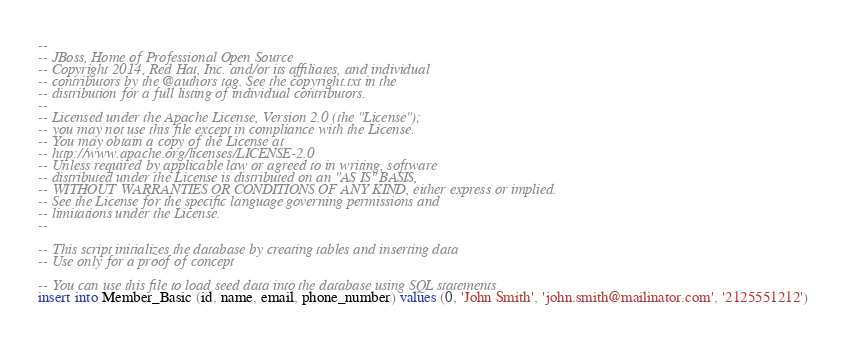Convert code to text. <code><loc_0><loc_0><loc_500><loc_500><_SQL_>--
-- JBoss, Home of Professional Open Source
-- Copyright 2014, Red Hat, Inc. and/or its affiliates, and individual
-- contributors by the @authors tag. See the copyright.txt in the
-- distribution for a full listing of individual contributors.
--
-- Licensed under the Apache License, Version 2.0 (the "License");
-- you may not use this file except in compliance with the License.
-- You may obtain a copy of the License at
-- http://www.apache.org/licenses/LICENSE-2.0
-- Unless required by applicable law or agreed to in writing, software
-- distributed under the License is distributed on an "AS IS" BASIS,
-- WITHOUT WARRANTIES OR CONDITIONS OF ANY KIND, either express or implied.
-- See the License for the specific language governing permissions and
-- limitations under the License.
--

-- This script initializes the database by creating tables and inserting data
-- Use only for a proof of concept

-- You can use this file to load seed data into the database using SQL statements
insert into Member_Basic (id, name, email, phone_number) values (0, 'John Smith', 'john.smith@mailinator.com', '2125551212')
</code> 